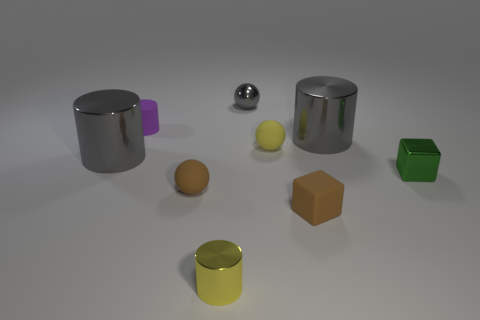Is the number of tiny brown cubes behind the tiny purple cylinder the same as the number of large cylinders?
Give a very brief answer. No. How many other objects are there of the same shape as the tiny purple thing?
Make the answer very short. 3. The purple object has what shape?
Keep it short and to the point. Cylinder. Is the material of the tiny brown block the same as the small yellow ball?
Ensure brevity in your answer.  Yes. Are there the same number of gray metal objects that are in front of the small gray metallic object and tiny yellow spheres that are in front of the green metal cube?
Your answer should be compact. No. Are there any yellow cylinders that are behind the big gray cylinder right of the small shiny object that is in front of the tiny green metal thing?
Your response must be concise. No. Do the yellow cylinder and the yellow sphere have the same size?
Ensure brevity in your answer.  Yes. What color is the large shiny object on the left side of the tiny yellow object to the left of the tiny thing behind the small purple thing?
Offer a terse response. Gray. How many metallic cylinders are the same color as the tiny metallic ball?
Your answer should be very brief. 2. What number of small things are purple matte cylinders or green matte blocks?
Keep it short and to the point. 1. 